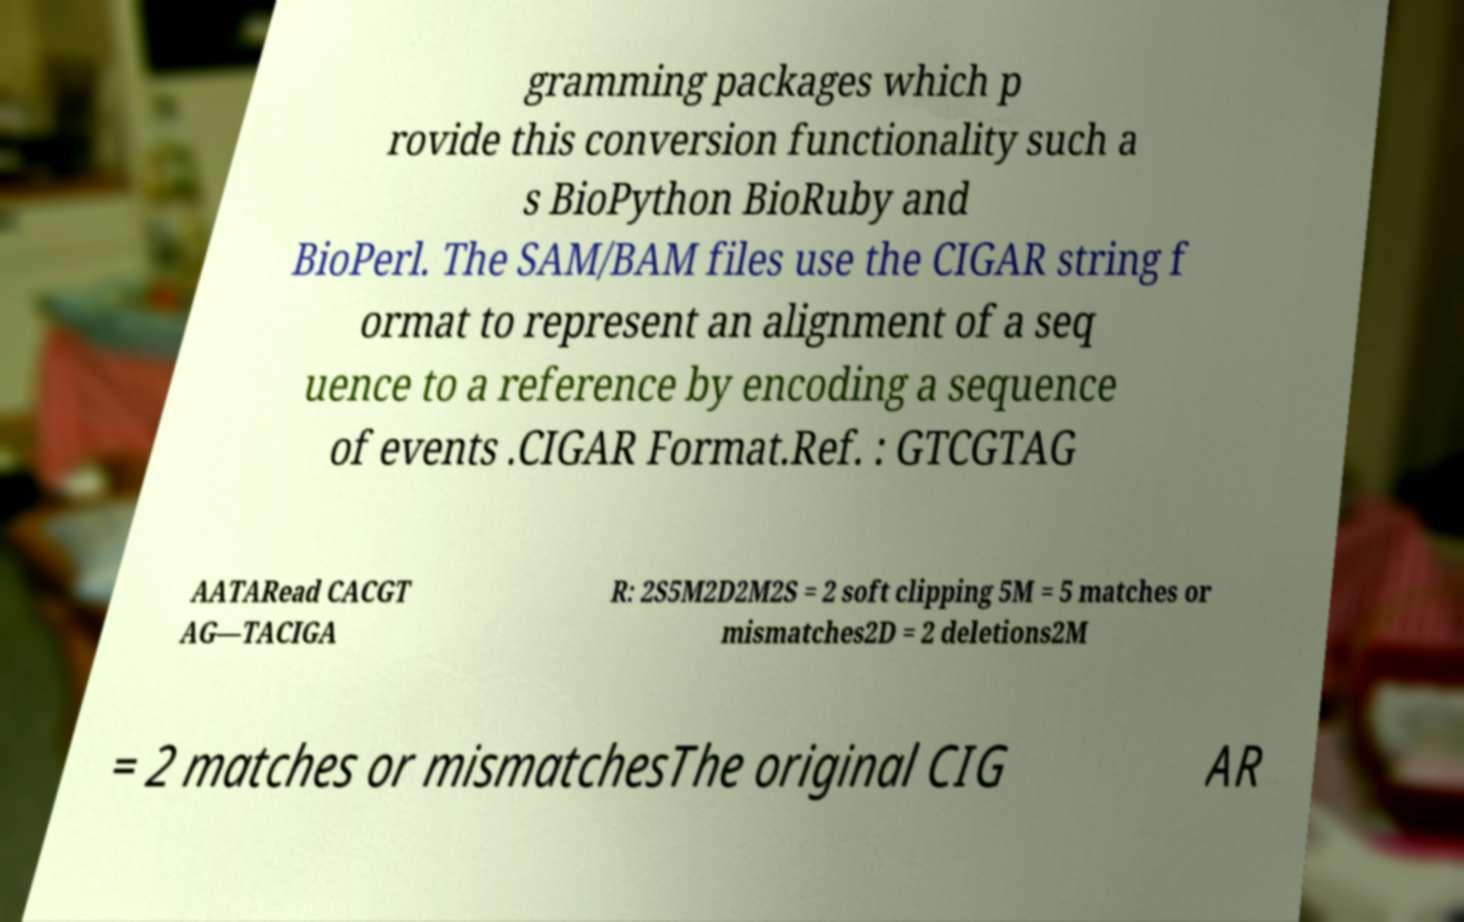Can you read and provide the text displayed in the image?This photo seems to have some interesting text. Can you extract and type it out for me? gramming packages which p rovide this conversion functionality such a s BioPython BioRuby and BioPerl. The SAM/BAM files use the CIGAR string f ormat to represent an alignment of a seq uence to a reference by encoding a sequence of events .CIGAR Format.Ref. : GTCGTAG AATARead CACGT AG—TACIGA R: 2S5M2D2M2S = 2 soft clipping 5M = 5 matches or mismatches2D = 2 deletions2M = 2 matches or mismatchesThe original CIG AR 